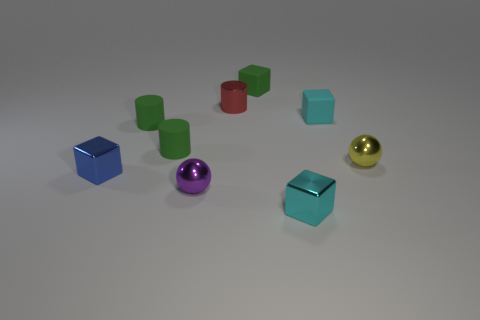Add 1 shiny cylinders. How many objects exist? 10 Add 5 small red metallic things. How many small red metallic things are left? 6 Add 6 small red metallic cylinders. How many small red metallic cylinders exist? 7 Subtract all blue cubes. How many cubes are left? 3 Subtract all green matte blocks. How many blocks are left? 3 Subtract 0 green balls. How many objects are left? 9 Subtract all cylinders. How many objects are left? 6 Subtract 1 cubes. How many cubes are left? 3 Subtract all blue cylinders. Subtract all gray blocks. How many cylinders are left? 3 Subtract all purple cylinders. How many yellow spheres are left? 1 